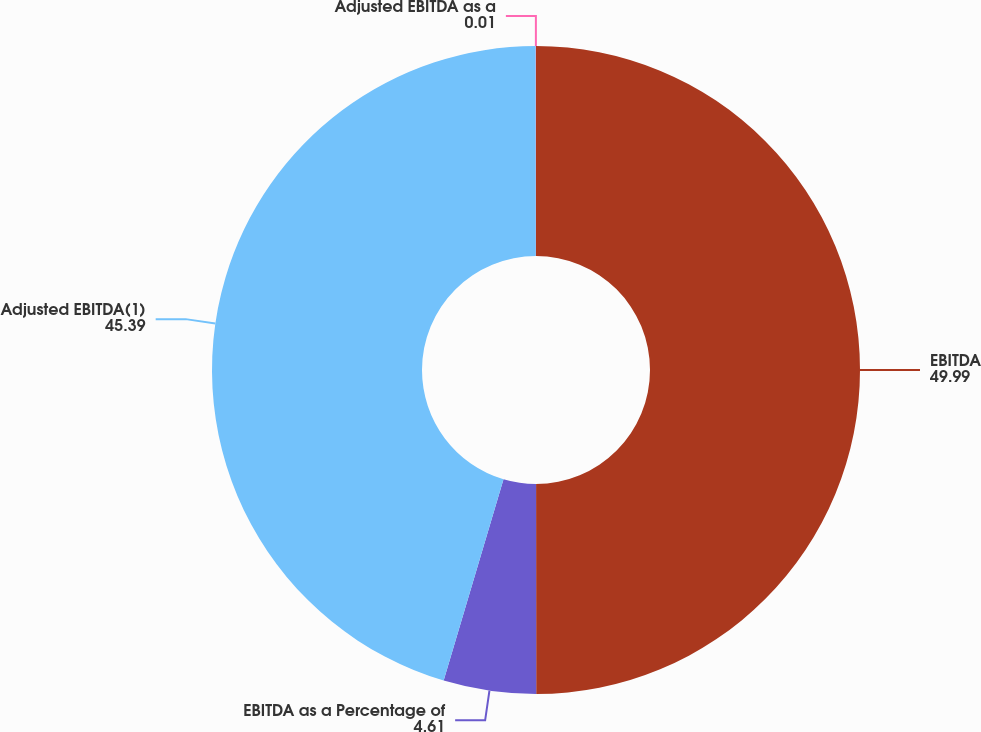<chart> <loc_0><loc_0><loc_500><loc_500><pie_chart><fcel>EBITDA<fcel>EBITDA as a Percentage of<fcel>Adjusted EBITDA(1)<fcel>Adjusted EBITDA as a<nl><fcel>49.99%<fcel>4.61%<fcel>45.39%<fcel>0.01%<nl></chart> 